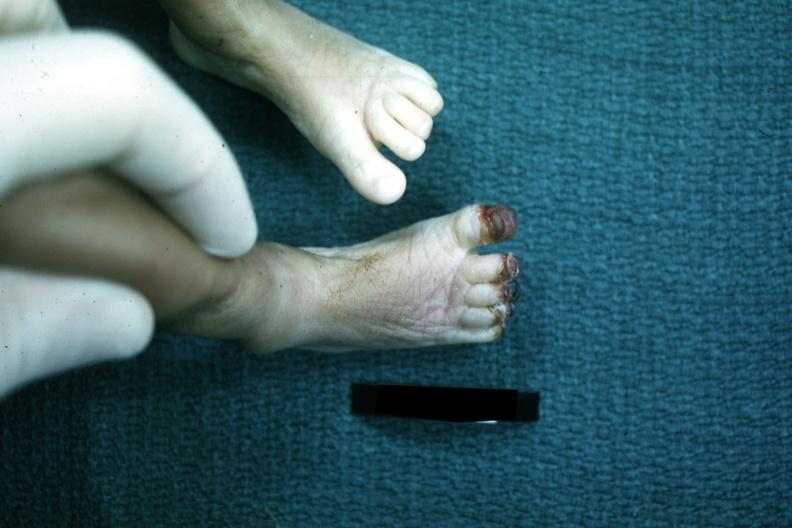what is present?
Answer the question using a single word or phrase. Gangrene 